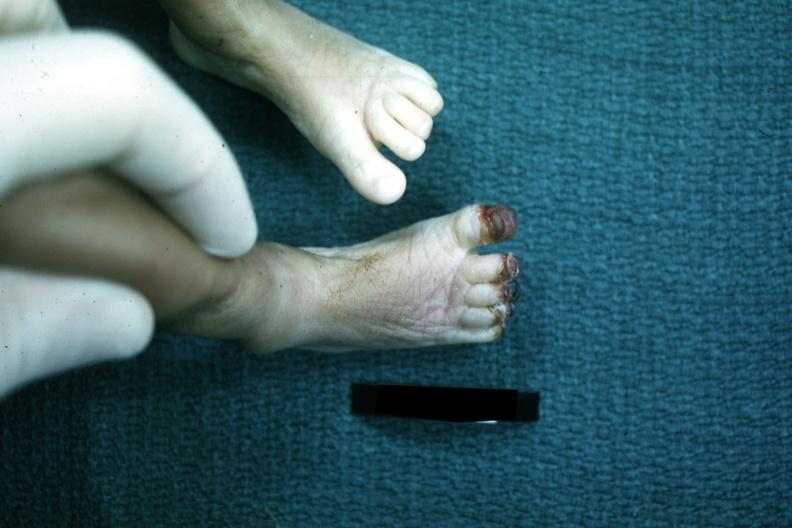what is present?
Answer the question using a single word or phrase. Gangrene 